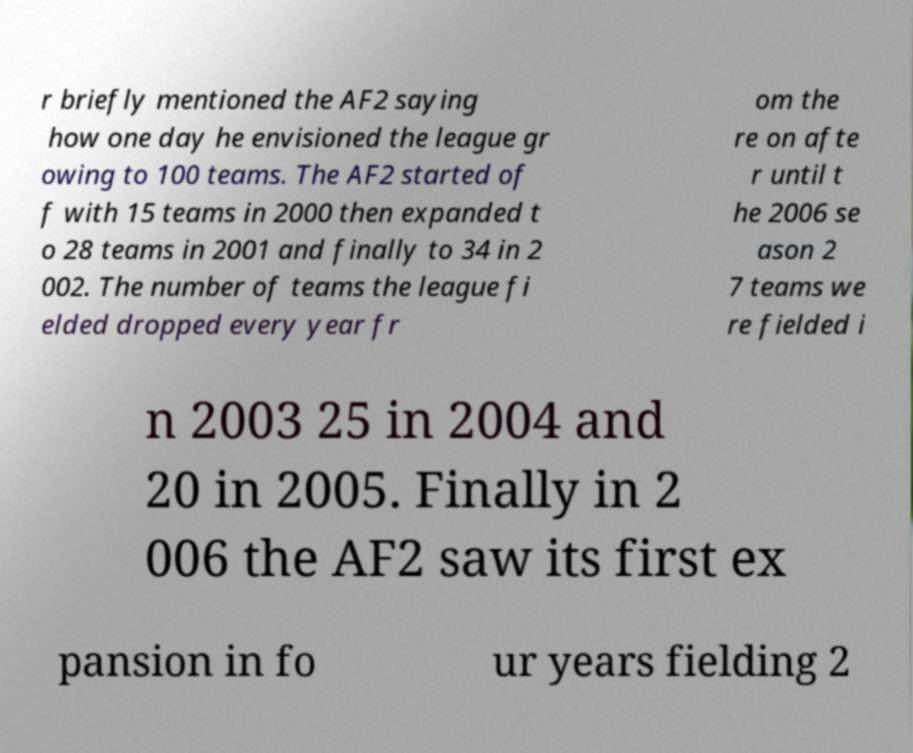What messages or text are displayed in this image? I need them in a readable, typed format. r briefly mentioned the AF2 saying how one day he envisioned the league gr owing to 100 teams. The AF2 started of f with 15 teams in 2000 then expanded t o 28 teams in 2001 and finally to 34 in 2 002. The number of teams the league fi elded dropped every year fr om the re on afte r until t he 2006 se ason 2 7 teams we re fielded i n 2003 25 in 2004 and 20 in 2005. Finally in 2 006 the AF2 saw its first ex pansion in fo ur years fielding 2 